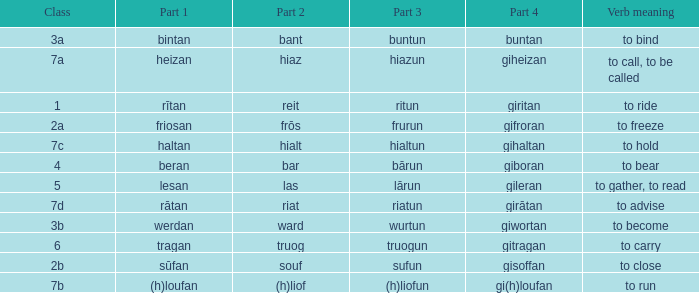What is the verb meaning of the word with part 3 "sufun"? To close. 